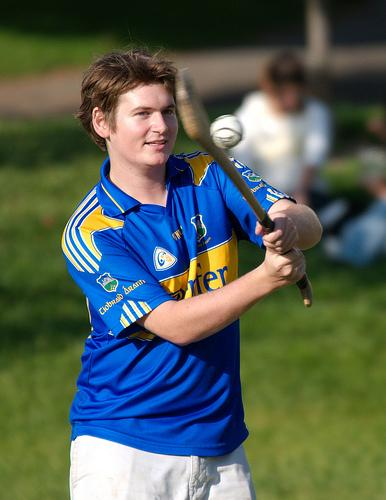Describe the dominant subject in the image, mentioning their attire and the game they are playing. The dominant subject is a boy wearing a blue and yellow jersey with white shorts, immersed in an exciting game of hurling as he swings his stick to hit a flying ball. In a concise manner, describe the main person and their sporting activity in the image. A hurling player in a blue and yellow jersey and white shorts swings a stick to strike a ball in the air. What is the core activity of the person in the image and what key features can be observed? The person is playing hurling, wearing a blue and yellow jersey with white shorts, and attempting to hit a white, airborne ball with a stick. Explain the scene in the image by highlighting the principal character and their sport-related actions. A boy playing hurling swings a stick to strike a white airborne ball, wearing a blue and yellow jersey and white shorts. Give a short description of the scene, emphasizing the central figure and their ongoing sports action. A boy dressed in a blue and yellow jersey and white shorts is in the midst of a hurling game, swinging a stick to hit an airborne white ball. What is the main event taking place in the image and who is participating in it? A boy in a blue and yellow jersey and white shorts is the main participant, engaging in a hurling match where he swings a stick to strike a ball in flight. Identify the primary subject and describe briefly what they are doing in the image. A young man, dressed in a blue and yellow short-sleeved jersey with white shorts, is actively engaged in a game of hurling, attempting to hit a ball in the air with a stick. What is the central focus of the image and what is the person in the image engaged in? The central focus is a boy participating in a hurling game, wearing a blue and yellow jersey and swinging a stick to hit a flying ball. Mention the main individual and their activity in the image, as well as any relevant clothing or accessories. A boy wearing a blue and yellow short-sleeved jersey and white shorts is hitting a hurling ball with a stick, while sporting a school emblem. Provide a brief description of the key elements and actions taking place in this image. A young man in a blue and yellow jersey is playing hurling, swinging a stick to hit a white ball in the air, with a blurry background and green grass. 